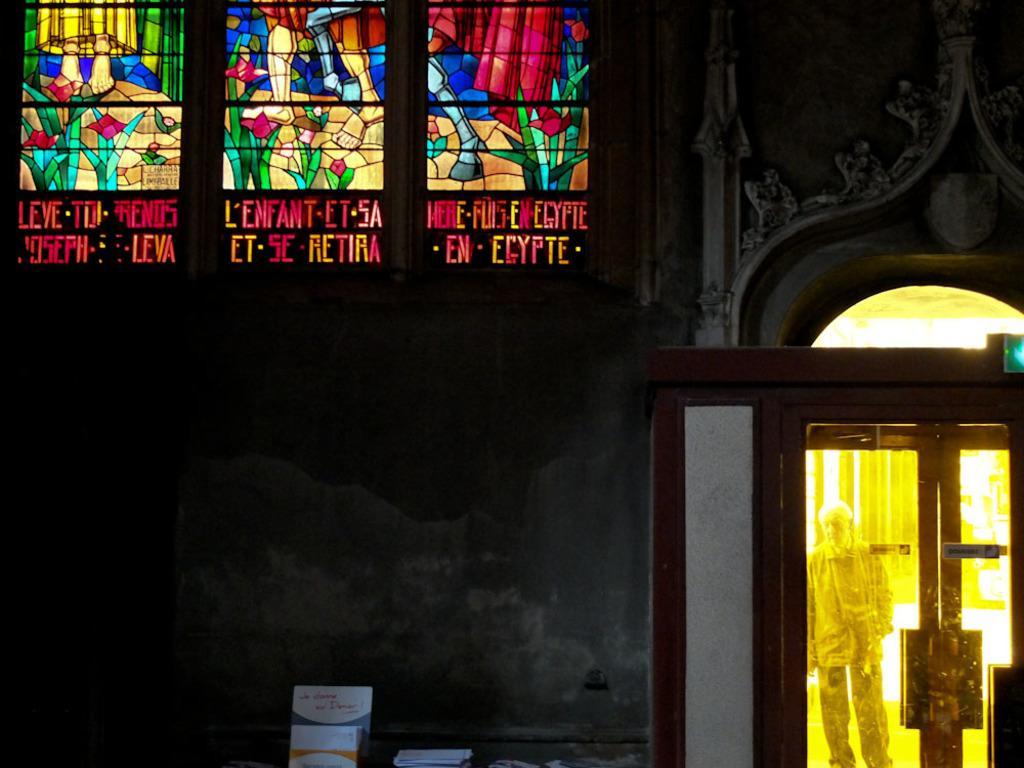How would you summarize this image in a sentence or two? In this picture we can see some objects, wall, doors and from a door we can see a man standing. 